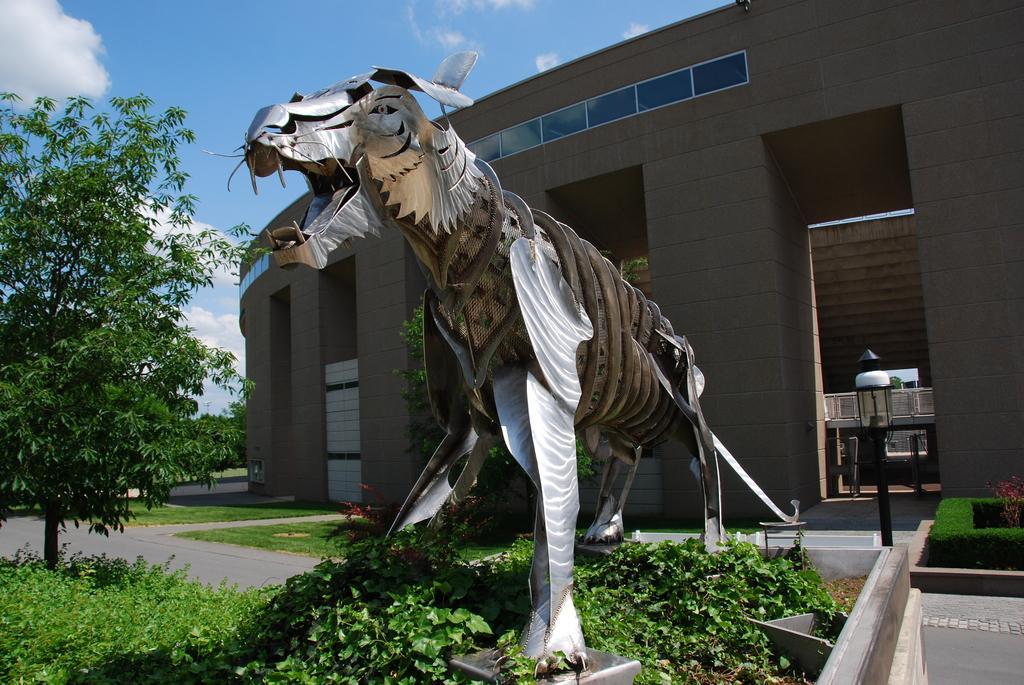Can you describe this image briefly? In the picture here is a building and in front of the building there is a statue of some animal and around the building there is a lot of greenery. 